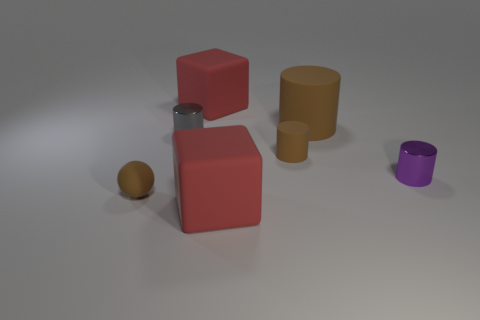What is the size of the other cylinder that is made of the same material as the gray cylinder?
Offer a terse response. Small. What is the shape of the brown object that is in front of the tiny gray metallic cylinder and to the right of the gray cylinder?
Ensure brevity in your answer.  Cylinder. Are there the same number of tiny gray shiny objects that are left of the tiny rubber cylinder and brown matte balls?
Keep it short and to the point. Yes. What number of things are either cyan spheres or big red things that are in front of the small brown matte sphere?
Make the answer very short. 1. Is there another tiny metallic thing of the same shape as the gray object?
Provide a succinct answer. Yes. Is the number of small cylinders behind the small purple cylinder the same as the number of matte cylinders that are to the left of the big cylinder?
Your answer should be very brief. No. What number of yellow objects are rubber things or rubber balls?
Give a very brief answer. 0. What number of other gray cylinders are the same size as the gray cylinder?
Provide a short and direct response. 0. There is a rubber object that is both in front of the big rubber cylinder and behind the small brown rubber ball; what color is it?
Provide a succinct answer. Brown. Are there more brown matte objects on the left side of the gray metal thing than large gray blocks?
Ensure brevity in your answer.  Yes. 